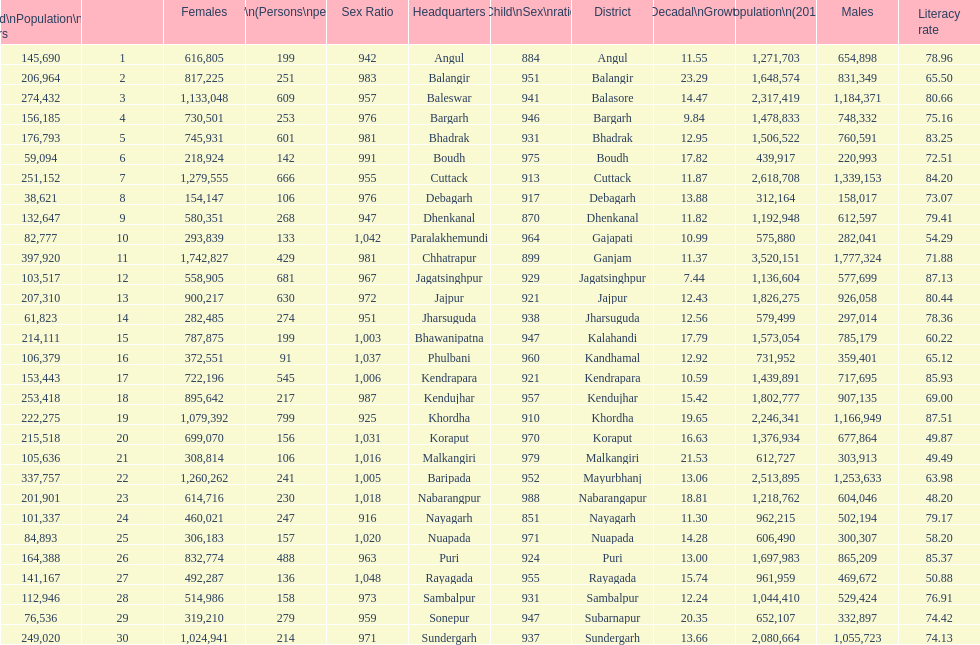Which district has a higher population, angul or cuttack? Cuttack. 